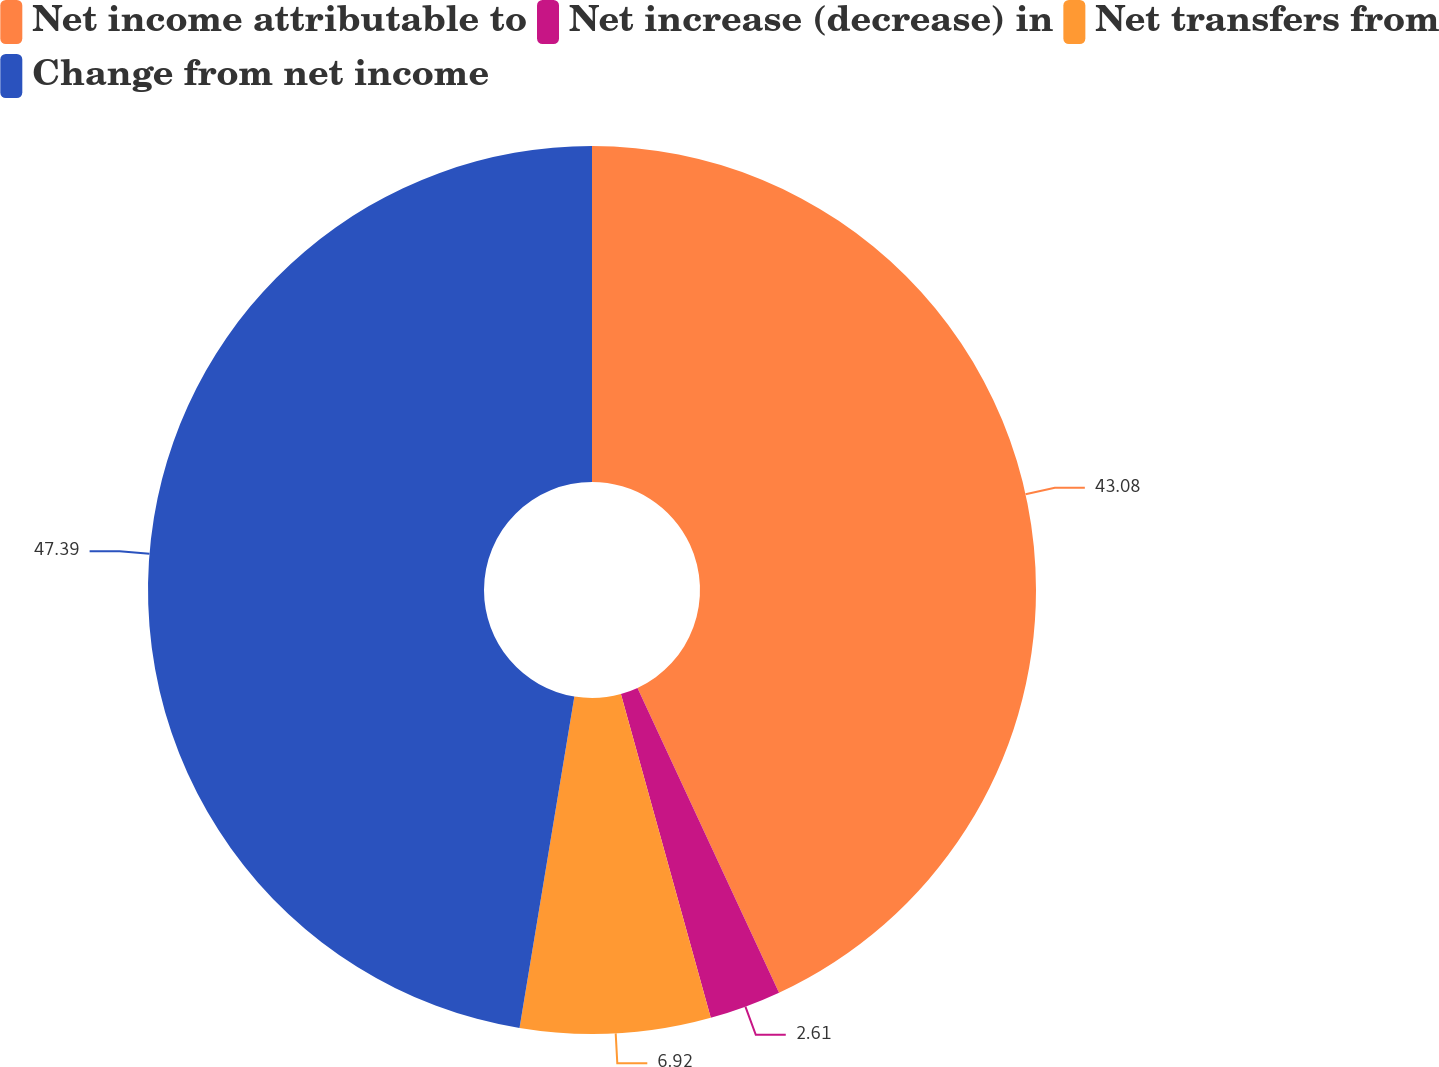Convert chart. <chart><loc_0><loc_0><loc_500><loc_500><pie_chart><fcel>Net income attributable to<fcel>Net increase (decrease) in<fcel>Net transfers from<fcel>Change from net income<nl><fcel>43.08%<fcel>2.61%<fcel>6.92%<fcel>47.39%<nl></chart> 